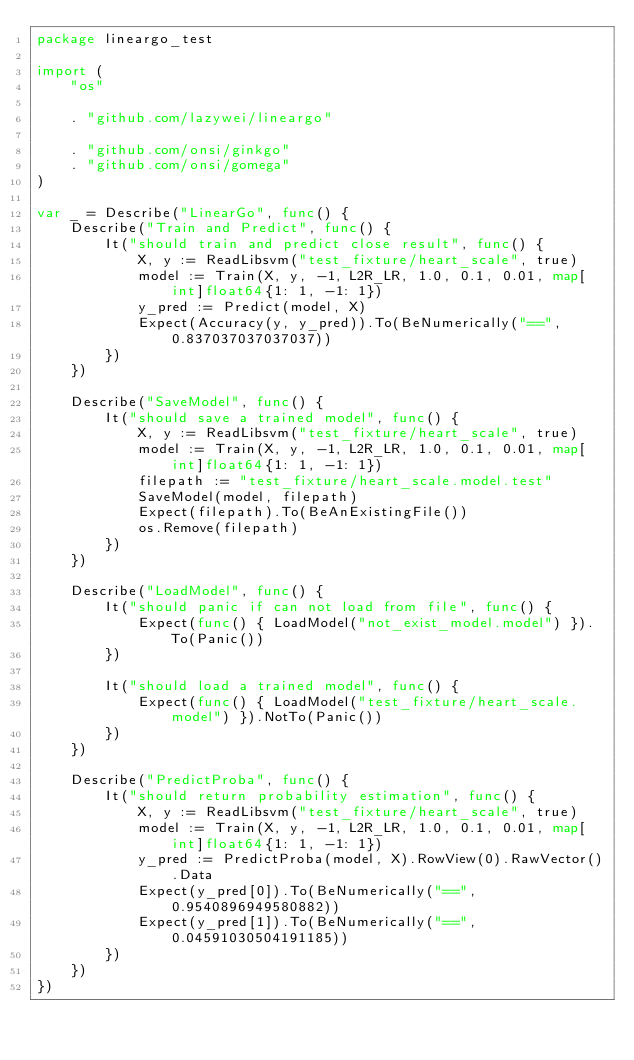Convert code to text. <code><loc_0><loc_0><loc_500><loc_500><_Go_>package lineargo_test

import (
	"os"

	. "github.com/lazywei/lineargo"

	. "github.com/onsi/ginkgo"
	. "github.com/onsi/gomega"
)

var _ = Describe("LinearGo", func() {
	Describe("Train and Predict", func() {
		It("should train and predict close result", func() {
			X, y := ReadLibsvm("test_fixture/heart_scale", true)
			model := Train(X, y, -1, L2R_LR, 1.0, 0.1, 0.01, map[int]float64{1: 1, -1: 1})
			y_pred := Predict(model, X)
			Expect(Accuracy(y, y_pred)).To(BeNumerically("==", 0.837037037037037))
		})
	})

	Describe("SaveModel", func() {
		It("should save a trained model", func() {
			X, y := ReadLibsvm("test_fixture/heart_scale", true)
			model := Train(X, y, -1, L2R_LR, 1.0, 0.1, 0.01, map[int]float64{1: 1, -1: 1})
			filepath := "test_fixture/heart_scale.model.test"
			SaveModel(model, filepath)
			Expect(filepath).To(BeAnExistingFile())
			os.Remove(filepath)
		})
	})

	Describe("LoadModel", func() {
		It("should panic if can not load from file", func() {
			Expect(func() { LoadModel("not_exist_model.model") }).To(Panic())
		})

		It("should load a trained model", func() {
			Expect(func() { LoadModel("test_fixture/heart_scale.model") }).NotTo(Panic())
		})
	})

	Describe("PredictProba", func() {
		It("should return probability estimation", func() {
			X, y := ReadLibsvm("test_fixture/heart_scale", true)
			model := Train(X, y, -1, L2R_LR, 1.0, 0.1, 0.01, map[int]float64{1: 1, -1: 1})
			y_pred := PredictProba(model, X).RowView(0).RawVector().Data
			Expect(y_pred[0]).To(BeNumerically("==", 0.9540896949580882))
			Expect(y_pred[1]).To(BeNumerically("==", 0.04591030504191185))
		})
	})
})
</code> 